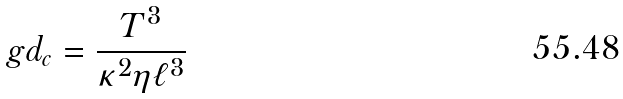Convert formula to latex. <formula><loc_0><loc_0><loc_500><loc_500>\ g d _ { c } = \frac { T ^ { 3 } } { \kappa ^ { 2 } \eta \ell ^ { 3 } }</formula> 